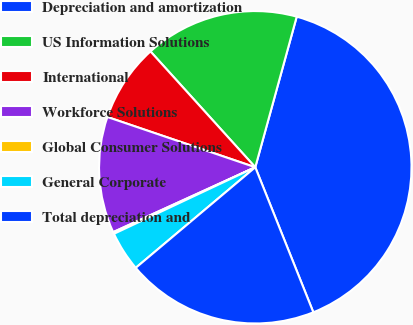Convert chart to OTSL. <chart><loc_0><loc_0><loc_500><loc_500><pie_chart><fcel>Depreciation and amortization<fcel>US Information Solutions<fcel>International<fcel>Workforce Solutions<fcel>Global Consumer Solutions<fcel>General Corporate<fcel>Total depreciation and<nl><fcel>39.67%<fcel>15.98%<fcel>8.08%<fcel>12.03%<fcel>0.19%<fcel>4.13%<fcel>19.93%<nl></chart> 